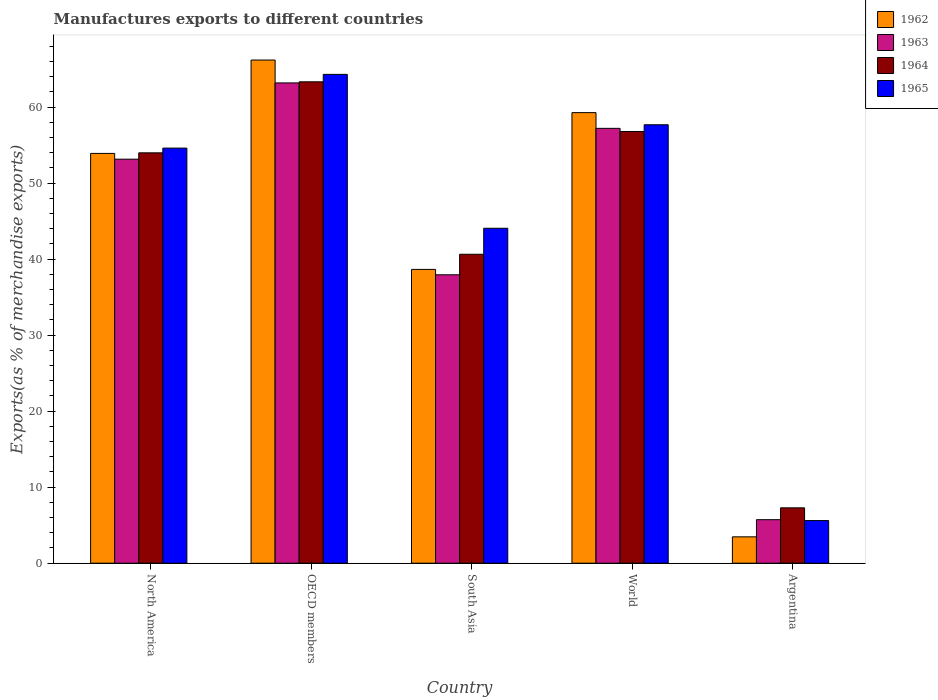How many groups of bars are there?
Provide a succinct answer. 5. Are the number of bars on each tick of the X-axis equal?
Make the answer very short. Yes. What is the label of the 4th group of bars from the left?
Offer a very short reply. World. What is the percentage of exports to different countries in 1962 in OECD members?
Offer a terse response. 66.19. Across all countries, what is the maximum percentage of exports to different countries in 1965?
Make the answer very short. 64.3. Across all countries, what is the minimum percentage of exports to different countries in 1965?
Provide a succinct answer. 5.61. In which country was the percentage of exports to different countries in 1965 maximum?
Give a very brief answer. OECD members. What is the total percentage of exports to different countries in 1962 in the graph?
Offer a terse response. 221.48. What is the difference between the percentage of exports to different countries in 1965 in South Asia and that in World?
Provide a short and direct response. -13.62. What is the difference between the percentage of exports to different countries in 1962 in OECD members and the percentage of exports to different countries in 1965 in South Asia?
Keep it short and to the point. 22.13. What is the average percentage of exports to different countries in 1965 per country?
Keep it short and to the point. 45.25. What is the difference between the percentage of exports to different countries of/in 1962 and percentage of exports to different countries of/in 1965 in Argentina?
Keep it short and to the point. -2.14. What is the ratio of the percentage of exports to different countries in 1962 in North America to that in South Asia?
Your answer should be very brief. 1.39. What is the difference between the highest and the second highest percentage of exports to different countries in 1962?
Your answer should be compact. 6.92. What is the difference between the highest and the lowest percentage of exports to different countries in 1964?
Offer a terse response. 56.04. Is the sum of the percentage of exports to different countries in 1964 in Argentina and North America greater than the maximum percentage of exports to different countries in 1962 across all countries?
Keep it short and to the point. No. Is it the case that in every country, the sum of the percentage of exports to different countries in 1964 and percentage of exports to different countries in 1963 is greater than the sum of percentage of exports to different countries in 1962 and percentage of exports to different countries in 1965?
Give a very brief answer. No. What does the 2nd bar from the left in North America represents?
Ensure brevity in your answer.  1963. What does the 3rd bar from the right in Argentina represents?
Keep it short and to the point. 1963. How many countries are there in the graph?
Make the answer very short. 5. What is the title of the graph?
Provide a succinct answer. Manufactures exports to different countries. Does "1967" appear as one of the legend labels in the graph?
Provide a short and direct response. No. What is the label or title of the Y-axis?
Give a very brief answer. Exports(as % of merchandise exports). What is the Exports(as % of merchandise exports) in 1962 in North America?
Keep it short and to the point. 53.91. What is the Exports(as % of merchandise exports) of 1963 in North America?
Provide a short and direct response. 53.15. What is the Exports(as % of merchandise exports) of 1964 in North America?
Your answer should be very brief. 53.98. What is the Exports(as % of merchandise exports) in 1965 in North America?
Offer a terse response. 54.61. What is the Exports(as % of merchandise exports) in 1962 in OECD members?
Ensure brevity in your answer.  66.19. What is the Exports(as % of merchandise exports) of 1963 in OECD members?
Ensure brevity in your answer.  63.18. What is the Exports(as % of merchandise exports) of 1964 in OECD members?
Make the answer very short. 63.32. What is the Exports(as % of merchandise exports) in 1965 in OECD members?
Ensure brevity in your answer.  64.3. What is the Exports(as % of merchandise exports) in 1962 in South Asia?
Provide a succinct answer. 38.65. What is the Exports(as % of merchandise exports) in 1963 in South Asia?
Your answer should be very brief. 37.94. What is the Exports(as % of merchandise exports) in 1964 in South Asia?
Your response must be concise. 40.64. What is the Exports(as % of merchandise exports) in 1965 in South Asia?
Provide a succinct answer. 44.06. What is the Exports(as % of merchandise exports) in 1962 in World?
Make the answer very short. 59.27. What is the Exports(as % of merchandise exports) of 1963 in World?
Make the answer very short. 57.2. What is the Exports(as % of merchandise exports) of 1964 in World?
Your answer should be very brief. 56.79. What is the Exports(as % of merchandise exports) of 1965 in World?
Your answer should be compact. 57.68. What is the Exports(as % of merchandise exports) in 1962 in Argentina?
Make the answer very short. 3.47. What is the Exports(as % of merchandise exports) in 1963 in Argentina?
Offer a terse response. 5.73. What is the Exports(as % of merchandise exports) in 1964 in Argentina?
Keep it short and to the point. 7.28. What is the Exports(as % of merchandise exports) in 1965 in Argentina?
Your answer should be compact. 5.61. Across all countries, what is the maximum Exports(as % of merchandise exports) in 1962?
Give a very brief answer. 66.19. Across all countries, what is the maximum Exports(as % of merchandise exports) in 1963?
Your answer should be compact. 63.18. Across all countries, what is the maximum Exports(as % of merchandise exports) of 1964?
Give a very brief answer. 63.32. Across all countries, what is the maximum Exports(as % of merchandise exports) in 1965?
Your answer should be compact. 64.3. Across all countries, what is the minimum Exports(as % of merchandise exports) in 1962?
Offer a terse response. 3.47. Across all countries, what is the minimum Exports(as % of merchandise exports) in 1963?
Your answer should be compact. 5.73. Across all countries, what is the minimum Exports(as % of merchandise exports) in 1964?
Provide a succinct answer. 7.28. Across all countries, what is the minimum Exports(as % of merchandise exports) of 1965?
Provide a succinct answer. 5.61. What is the total Exports(as % of merchandise exports) in 1962 in the graph?
Your response must be concise. 221.48. What is the total Exports(as % of merchandise exports) of 1963 in the graph?
Your answer should be compact. 217.2. What is the total Exports(as % of merchandise exports) in 1964 in the graph?
Your answer should be very brief. 222.02. What is the total Exports(as % of merchandise exports) in 1965 in the graph?
Provide a short and direct response. 226.25. What is the difference between the Exports(as % of merchandise exports) in 1962 in North America and that in OECD members?
Offer a very short reply. -12.28. What is the difference between the Exports(as % of merchandise exports) in 1963 in North America and that in OECD members?
Offer a very short reply. -10.03. What is the difference between the Exports(as % of merchandise exports) of 1964 in North America and that in OECD members?
Make the answer very short. -9.34. What is the difference between the Exports(as % of merchandise exports) in 1965 in North America and that in OECD members?
Your answer should be compact. -9.7. What is the difference between the Exports(as % of merchandise exports) of 1962 in North America and that in South Asia?
Give a very brief answer. 15.26. What is the difference between the Exports(as % of merchandise exports) of 1963 in North America and that in South Asia?
Offer a terse response. 15.21. What is the difference between the Exports(as % of merchandise exports) of 1964 in North America and that in South Asia?
Your answer should be very brief. 13.34. What is the difference between the Exports(as % of merchandise exports) in 1965 in North America and that in South Asia?
Offer a very short reply. 10.54. What is the difference between the Exports(as % of merchandise exports) in 1962 in North America and that in World?
Your answer should be compact. -5.36. What is the difference between the Exports(as % of merchandise exports) in 1963 in North America and that in World?
Make the answer very short. -4.06. What is the difference between the Exports(as % of merchandise exports) in 1964 in North America and that in World?
Provide a succinct answer. -2.81. What is the difference between the Exports(as % of merchandise exports) in 1965 in North America and that in World?
Provide a succinct answer. -3.07. What is the difference between the Exports(as % of merchandise exports) in 1962 in North America and that in Argentina?
Provide a short and direct response. 50.44. What is the difference between the Exports(as % of merchandise exports) in 1963 in North America and that in Argentina?
Offer a terse response. 47.42. What is the difference between the Exports(as % of merchandise exports) in 1964 in North America and that in Argentina?
Provide a short and direct response. 46.7. What is the difference between the Exports(as % of merchandise exports) of 1965 in North America and that in Argentina?
Your response must be concise. 49. What is the difference between the Exports(as % of merchandise exports) in 1962 in OECD members and that in South Asia?
Your answer should be very brief. 27.54. What is the difference between the Exports(as % of merchandise exports) in 1963 in OECD members and that in South Asia?
Offer a very short reply. 25.24. What is the difference between the Exports(as % of merchandise exports) of 1964 in OECD members and that in South Asia?
Keep it short and to the point. 22.68. What is the difference between the Exports(as % of merchandise exports) in 1965 in OECD members and that in South Asia?
Make the answer very short. 20.24. What is the difference between the Exports(as % of merchandise exports) in 1962 in OECD members and that in World?
Your answer should be very brief. 6.92. What is the difference between the Exports(as % of merchandise exports) of 1963 in OECD members and that in World?
Your response must be concise. 5.98. What is the difference between the Exports(as % of merchandise exports) of 1964 in OECD members and that in World?
Ensure brevity in your answer.  6.53. What is the difference between the Exports(as % of merchandise exports) of 1965 in OECD members and that in World?
Give a very brief answer. 6.63. What is the difference between the Exports(as % of merchandise exports) of 1962 in OECD members and that in Argentina?
Provide a succinct answer. 62.72. What is the difference between the Exports(as % of merchandise exports) of 1963 in OECD members and that in Argentina?
Offer a very short reply. 57.46. What is the difference between the Exports(as % of merchandise exports) in 1964 in OECD members and that in Argentina?
Make the answer very short. 56.04. What is the difference between the Exports(as % of merchandise exports) of 1965 in OECD members and that in Argentina?
Give a very brief answer. 58.69. What is the difference between the Exports(as % of merchandise exports) in 1962 in South Asia and that in World?
Give a very brief answer. -20.62. What is the difference between the Exports(as % of merchandise exports) in 1963 in South Asia and that in World?
Your answer should be compact. -19.26. What is the difference between the Exports(as % of merchandise exports) in 1964 in South Asia and that in World?
Your answer should be compact. -16.15. What is the difference between the Exports(as % of merchandise exports) of 1965 in South Asia and that in World?
Provide a succinct answer. -13.62. What is the difference between the Exports(as % of merchandise exports) in 1962 in South Asia and that in Argentina?
Give a very brief answer. 35.18. What is the difference between the Exports(as % of merchandise exports) in 1963 in South Asia and that in Argentina?
Your answer should be very brief. 32.21. What is the difference between the Exports(as % of merchandise exports) of 1964 in South Asia and that in Argentina?
Make the answer very short. 33.36. What is the difference between the Exports(as % of merchandise exports) of 1965 in South Asia and that in Argentina?
Your answer should be compact. 38.45. What is the difference between the Exports(as % of merchandise exports) of 1962 in World and that in Argentina?
Give a very brief answer. 55.8. What is the difference between the Exports(as % of merchandise exports) in 1963 in World and that in Argentina?
Provide a succinct answer. 51.48. What is the difference between the Exports(as % of merchandise exports) of 1964 in World and that in Argentina?
Give a very brief answer. 49.51. What is the difference between the Exports(as % of merchandise exports) of 1965 in World and that in Argentina?
Your answer should be compact. 52.07. What is the difference between the Exports(as % of merchandise exports) in 1962 in North America and the Exports(as % of merchandise exports) in 1963 in OECD members?
Make the answer very short. -9.27. What is the difference between the Exports(as % of merchandise exports) of 1962 in North America and the Exports(as % of merchandise exports) of 1964 in OECD members?
Provide a short and direct response. -9.42. What is the difference between the Exports(as % of merchandise exports) in 1962 in North America and the Exports(as % of merchandise exports) in 1965 in OECD members?
Make the answer very short. -10.4. What is the difference between the Exports(as % of merchandise exports) in 1963 in North America and the Exports(as % of merchandise exports) in 1964 in OECD members?
Ensure brevity in your answer.  -10.18. What is the difference between the Exports(as % of merchandise exports) in 1963 in North America and the Exports(as % of merchandise exports) in 1965 in OECD members?
Offer a terse response. -11.15. What is the difference between the Exports(as % of merchandise exports) of 1964 in North America and the Exports(as % of merchandise exports) of 1965 in OECD members?
Give a very brief answer. -10.32. What is the difference between the Exports(as % of merchandise exports) in 1962 in North America and the Exports(as % of merchandise exports) in 1963 in South Asia?
Your answer should be compact. 15.97. What is the difference between the Exports(as % of merchandise exports) of 1962 in North America and the Exports(as % of merchandise exports) of 1964 in South Asia?
Make the answer very short. 13.27. What is the difference between the Exports(as % of merchandise exports) of 1962 in North America and the Exports(as % of merchandise exports) of 1965 in South Asia?
Make the answer very short. 9.85. What is the difference between the Exports(as % of merchandise exports) of 1963 in North America and the Exports(as % of merchandise exports) of 1964 in South Asia?
Keep it short and to the point. 12.51. What is the difference between the Exports(as % of merchandise exports) in 1963 in North America and the Exports(as % of merchandise exports) in 1965 in South Asia?
Give a very brief answer. 9.09. What is the difference between the Exports(as % of merchandise exports) of 1964 in North America and the Exports(as % of merchandise exports) of 1965 in South Asia?
Your response must be concise. 9.92. What is the difference between the Exports(as % of merchandise exports) in 1962 in North America and the Exports(as % of merchandise exports) in 1963 in World?
Your answer should be compact. -3.3. What is the difference between the Exports(as % of merchandise exports) of 1962 in North America and the Exports(as % of merchandise exports) of 1964 in World?
Your answer should be compact. -2.88. What is the difference between the Exports(as % of merchandise exports) of 1962 in North America and the Exports(as % of merchandise exports) of 1965 in World?
Give a very brief answer. -3.77. What is the difference between the Exports(as % of merchandise exports) of 1963 in North America and the Exports(as % of merchandise exports) of 1964 in World?
Your answer should be very brief. -3.64. What is the difference between the Exports(as % of merchandise exports) in 1963 in North America and the Exports(as % of merchandise exports) in 1965 in World?
Ensure brevity in your answer.  -4.53. What is the difference between the Exports(as % of merchandise exports) of 1964 in North America and the Exports(as % of merchandise exports) of 1965 in World?
Offer a terse response. -3.69. What is the difference between the Exports(as % of merchandise exports) in 1962 in North America and the Exports(as % of merchandise exports) in 1963 in Argentina?
Keep it short and to the point. 48.18. What is the difference between the Exports(as % of merchandise exports) in 1962 in North America and the Exports(as % of merchandise exports) in 1964 in Argentina?
Provide a succinct answer. 46.62. What is the difference between the Exports(as % of merchandise exports) of 1962 in North America and the Exports(as % of merchandise exports) of 1965 in Argentina?
Give a very brief answer. 48.3. What is the difference between the Exports(as % of merchandise exports) in 1963 in North America and the Exports(as % of merchandise exports) in 1964 in Argentina?
Offer a terse response. 45.87. What is the difference between the Exports(as % of merchandise exports) in 1963 in North America and the Exports(as % of merchandise exports) in 1965 in Argentina?
Keep it short and to the point. 47.54. What is the difference between the Exports(as % of merchandise exports) in 1964 in North America and the Exports(as % of merchandise exports) in 1965 in Argentina?
Your response must be concise. 48.37. What is the difference between the Exports(as % of merchandise exports) of 1962 in OECD members and the Exports(as % of merchandise exports) of 1963 in South Asia?
Ensure brevity in your answer.  28.25. What is the difference between the Exports(as % of merchandise exports) in 1962 in OECD members and the Exports(as % of merchandise exports) in 1964 in South Asia?
Give a very brief answer. 25.55. What is the difference between the Exports(as % of merchandise exports) in 1962 in OECD members and the Exports(as % of merchandise exports) in 1965 in South Asia?
Ensure brevity in your answer.  22.13. What is the difference between the Exports(as % of merchandise exports) of 1963 in OECD members and the Exports(as % of merchandise exports) of 1964 in South Asia?
Offer a terse response. 22.54. What is the difference between the Exports(as % of merchandise exports) of 1963 in OECD members and the Exports(as % of merchandise exports) of 1965 in South Asia?
Your answer should be very brief. 19.12. What is the difference between the Exports(as % of merchandise exports) in 1964 in OECD members and the Exports(as % of merchandise exports) in 1965 in South Asia?
Your response must be concise. 19.26. What is the difference between the Exports(as % of merchandise exports) of 1962 in OECD members and the Exports(as % of merchandise exports) of 1963 in World?
Make the answer very short. 8.99. What is the difference between the Exports(as % of merchandise exports) of 1962 in OECD members and the Exports(as % of merchandise exports) of 1964 in World?
Your answer should be compact. 9.4. What is the difference between the Exports(as % of merchandise exports) of 1962 in OECD members and the Exports(as % of merchandise exports) of 1965 in World?
Give a very brief answer. 8.51. What is the difference between the Exports(as % of merchandise exports) in 1963 in OECD members and the Exports(as % of merchandise exports) in 1964 in World?
Give a very brief answer. 6.39. What is the difference between the Exports(as % of merchandise exports) of 1963 in OECD members and the Exports(as % of merchandise exports) of 1965 in World?
Your response must be concise. 5.5. What is the difference between the Exports(as % of merchandise exports) in 1964 in OECD members and the Exports(as % of merchandise exports) in 1965 in World?
Keep it short and to the point. 5.65. What is the difference between the Exports(as % of merchandise exports) of 1962 in OECD members and the Exports(as % of merchandise exports) of 1963 in Argentina?
Keep it short and to the point. 60.46. What is the difference between the Exports(as % of merchandise exports) in 1962 in OECD members and the Exports(as % of merchandise exports) in 1964 in Argentina?
Ensure brevity in your answer.  58.91. What is the difference between the Exports(as % of merchandise exports) in 1962 in OECD members and the Exports(as % of merchandise exports) in 1965 in Argentina?
Your answer should be compact. 60.58. What is the difference between the Exports(as % of merchandise exports) of 1963 in OECD members and the Exports(as % of merchandise exports) of 1964 in Argentina?
Your response must be concise. 55.9. What is the difference between the Exports(as % of merchandise exports) in 1963 in OECD members and the Exports(as % of merchandise exports) in 1965 in Argentina?
Give a very brief answer. 57.57. What is the difference between the Exports(as % of merchandise exports) in 1964 in OECD members and the Exports(as % of merchandise exports) in 1965 in Argentina?
Give a very brief answer. 57.71. What is the difference between the Exports(as % of merchandise exports) of 1962 in South Asia and the Exports(as % of merchandise exports) of 1963 in World?
Provide a short and direct response. -18.56. What is the difference between the Exports(as % of merchandise exports) in 1962 in South Asia and the Exports(as % of merchandise exports) in 1964 in World?
Provide a succinct answer. -18.14. What is the difference between the Exports(as % of merchandise exports) in 1962 in South Asia and the Exports(as % of merchandise exports) in 1965 in World?
Offer a terse response. -19.03. What is the difference between the Exports(as % of merchandise exports) in 1963 in South Asia and the Exports(as % of merchandise exports) in 1964 in World?
Your response must be concise. -18.85. What is the difference between the Exports(as % of merchandise exports) of 1963 in South Asia and the Exports(as % of merchandise exports) of 1965 in World?
Offer a terse response. -19.74. What is the difference between the Exports(as % of merchandise exports) of 1964 in South Asia and the Exports(as % of merchandise exports) of 1965 in World?
Keep it short and to the point. -17.04. What is the difference between the Exports(as % of merchandise exports) of 1962 in South Asia and the Exports(as % of merchandise exports) of 1963 in Argentina?
Your response must be concise. 32.92. What is the difference between the Exports(as % of merchandise exports) in 1962 in South Asia and the Exports(as % of merchandise exports) in 1964 in Argentina?
Your answer should be compact. 31.37. What is the difference between the Exports(as % of merchandise exports) of 1962 in South Asia and the Exports(as % of merchandise exports) of 1965 in Argentina?
Your response must be concise. 33.04. What is the difference between the Exports(as % of merchandise exports) in 1963 in South Asia and the Exports(as % of merchandise exports) in 1964 in Argentina?
Your answer should be very brief. 30.66. What is the difference between the Exports(as % of merchandise exports) in 1963 in South Asia and the Exports(as % of merchandise exports) in 1965 in Argentina?
Give a very brief answer. 32.33. What is the difference between the Exports(as % of merchandise exports) of 1964 in South Asia and the Exports(as % of merchandise exports) of 1965 in Argentina?
Your response must be concise. 35.03. What is the difference between the Exports(as % of merchandise exports) in 1962 in World and the Exports(as % of merchandise exports) in 1963 in Argentina?
Your answer should be very brief. 53.55. What is the difference between the Exports(as % of merchandise exports) of 1962 in World and the Exports(as % of merchandise exports) of 1964 in Argentina?
Give a very brief answer. 51.99. What is the difference between the Exports(as % of merchandise exports) in 1962 in World and the Exports(as % of merchandise exports) in 1965 in Argentina?
Provide a succinct answer. 53.66. What is the difference between the Exports(as % of merchandise exports) of 1963 in World and the Exports(as % of merchandise exports) of 1964 in Argentina?
Make the answer very short. 49.92. What is the difference between the Exports(as % of merchandise exports) of 1963 in World and the Exports(as % of merchandise exports) of 1965 in Argentina?
Your answer should be compact. 51.59. What is the difference between the Exports(as % of merchandise exports) of 1964 in World and the Exports(as % of merchandise exports) of 1965 in Argentina?
Your answer should be very brief. 51.18. What is the average Exports(as % of merchandise exports) of 1962 per country?
Offer a very short reply. 44.3. What is the average Exports(as % of merchandise exports) in 1963 per country?
Your answer should be compact. 43.44. What is the average Exports(as % of merchandise exports) of 1964 per country?
Offer a terse response. 44.4. What is the average Exports(as % of merchandise exports) in 1965 per country?
Give a very brief answer. 45.25. What is the difference between the Exports(as % of merchandise exports) of 1962 and Exports(as % of merchandise exports) of 1963 in North America?
Keep it short and to the point. 0.76. What is the difference between the Exports(as % of merchandise exports) of 1962 and Exports(as % of merchandise exports) of 1964 in North America?
Your answer should be very brief. -0.08. What is the difference between the Exports(as % of merchandise exports) in 1962 and Exports(as % of merchandise exports) in 1965 in North America?
Your answer should be very brief. -0.7. What is the difference between the Exports(as % of merchandise exports) in 1963 and Exports(as % of merchandise exports) in 1964 in North America?
Offer a terse response. -0.84. What is the difference between the Exports(as % of merchandise exports) in 1963 and Exports(as % of merchandise exports) in 1965 in North America?
Offer a very short reply. -1.46. What is the difference between the Exports(as % of merchandise exports) in 1964 and Exports(as % of merchandise exports) in 1965 in North America?
Your response must be concise. -0.62. What is the difference between the Exports(as % of merchandise exports) in 1962 and Exports(as % of merchandise exports) in 1963 in OECD members?
Keep it short and to the point. 3.01. What is the difference between the Exports(as % of merchandise exports) in 1962 and Exports(as % of merchandise exports) in 1964 in OECD members?
Keep it short and to the point. 2.87. What is the difference between the Exports(as % of merchandise exports) of 1962 and Exports(as % of merchandise exports) of 1965 in OECD members?
Your response must be concise. 1.89. What is the difference between the Exports(as % of merchandise exports) in 1963 and Exports(as % of merchandise exports) in 1964 in OECD members?
Your answer should be compact. -0.14. What is the difference between the Exports(as % of merchandise exports) in 1963 and Exports(as % of merchandise exports) in 1965 in OECD members?
Offer a terse response. -1.12. What is the difference between the Exports(as % of merchandise exports) of 1964 and Exports(as % of merchandise exports) of 1965 in OECD members?
Make the answer very short. -0.98. What is the difference between the Exports(as % of merchandise exports) of 1962 and Exports(as % of merchandise exports) of 1963 in South Asia?
Keep it short and to the point. 0.71. What is the difference between the Exports(as % of merchandise exports) in 1962 and Exports(as % of merchandise exports) in 1964 in South Asia?
Provide a short and direct response. -1.99. What is the difference between the Exports(as % of merchandise exports) of 1962 and Exports(as % of merchandise exports) of 1965 in South Asia?
Provide a succinct answer. -5.41. What is the difference between the Exports(as % of merchandise exports) in 1963 and Exports(as % of merchandise exports) in 1964 in South Asia?
Provide a short and direct response. -2.7. What is the difference between the Exports(as % of merchandise exports) in 1963 and Exports(as % of merchandise exports) in 1965 in South Asia?
Offer a terse response. -6.12. What is the difference between the Exports(as % of merchandise exports) in 1964 and Exports(as % of merchandise exports) in 1965 in South Asia?
Provide a short and direct response. -3.42. What is the difference between the Exports(as % of merchandise exports) in 1962 and Exports(as % of merchandise exports) in 1963 in World?
Make the answer very short. 2.07. What is the difference between the Exports(as % of merchandise exports) of 1962 and Exports(as % of merchandise exports) of 1964 in World?
Offer a terse response. 2.48. What is the difference between the Exports(as % of merchandise exports) of 1962 and Exports(as % of merchandise exports) of 1965 in World?
Your answer should be compact. 1.59. What is the difference between the Exports(as % of merchandise exports) in 1963 and Exports(as % of merchandise exports) in 1964 in World?
Ensure brevity in your answer.  0.41. What is the difference between the Exports(as % of merchandise exports) in 1963 and Exports(as % of merchandise exports) in 1965 in World?
Provide a short and direct response. -0.47. What is the difference between the Exports(as % of merchandise exports) in 1964 and Exports(as % of merchandise exports) in 1965 in World?
Your answer should be very brief. -0.89. What is the difference between the Exports(as % of merchandise exports) of 1962 and Exports(as % of merchandise exports) of 1963 in Argentina?
Give a very brief answer. -2.26. What is the difference between the Exports(as % of merchandise exports) of 1962 and Exports(as % of merchandise exports) of 1964 in Argentina?
Make the answer very short. -3.81. What is the difference between the Exports(as % of merchandise exports) of 1962 and Exports(as % of merchandise exports) of 1965 in Argentina?
Keep it short and to the point. -2.14. What is the difference between the Exports(as % of merchandise exports) of 1963 and Exports(as % of merchandise exports) of 1964 in Argentina?
Your answer should be very brief. -1.56. What is the difference between the Exports(as % of merchandise exports) in 1963 and Exports(as % of merchandise exports) in 1965 in Argentina?
Your response must be concise. 0.12. What is the difference between the Exports(as % of merchandise exports) of 1964 and Exports(as % of merchandise exports) of 1965 in Argentina?
Provide a succinct answer. 1.67. What is the ratio of the Exports(as % of merchandise exports) in 1962 in North America to that in OECD members?
Your answer should be very brief. 0.81. What is the ratio of the Exports(as % of merchandise exports) of 1963 in North America to that in OECD members?
Your answer should be compact. 0.84. What is the ratio of the Exports(as % of merchandise exports) in 1964 in North America to that in OECD members?
Your response must be concise. 0.85. What is the ratio of the Exports(as % of merchandise exports) of 1965 in North America to that in OECD members?
Offer a terse response. 0.85. What is the ratio of the Exports(as % of merchandise exports) of 1962 in North America to that in South Asia?
Offer a very short reply. 1.39. What is the ratio of the Exports(as % of merchandise exports) of 1963 in North America to that in South Asia?
Offer a terse response. 1.4. What is the ratio of the Exports(as % of merchandise exports) of 1964 in North America to that in South Asia?
Keep it short and to the point. 1.33. What is the ratio of the Exports(as % of merchandise exports) in 1965 in North America to that in South Asia?
Your response must be concise. 1.24. What is the ratio of the Exports(as % of merchandise exports) in 1962 in North America to that in World?
Your response must be concise. 0.91. What is the ratio of the Exports(as % of merchandise exports) of 1963 in North America to that in World?
Give a very brief answer. 0.93. What is the ratio of the Exports(as % of merchandise exports) in 1964 in North America to that in World?
Keep it short and to the point. 0.95. What is the ratio of the Exports(as % of merchandise exports) of 1965 in North America to that in World?
Give a very brief answer. 0.95. What is the ratio of the Exports(as % of merchandise exports) in 1962 in North America to that in Argentina?
Your answer should be very brief. 15.54. What is the ratio of the Exports(as % of merchandise exports) of 1963 in North America to that in Argentina?
Ensure brevity in your answer.  9.28. What is the ratio of the Exports(as % of merchandise exports) in 1964 in North America to that in Argentina?
Your answer should be compact. 7.41. What is the ratio of the Exports(as % of merchandise exports) of 1965 in North America to that in Argentina?
Provide a short and direct response. 9.74. What is the ratio of the Exports(as % of merchandise exports) of 1962 in OECD members to that in South Asia?
Offer a very short reply. 1.71. What is the ratio of the Exports(as % of merchandise exports) in 1963 in OECD members to that in South Asia?
Offer a terse response. 1.67. What is the ratio of the Exports(as % of merchandise exports) in 1964 in OECD members to that in South Asia?
Make the answer very short. 1.56. What is the ratio of the Exports(as % of merchandise exports) of 1965 in OECD members to that in South Asia?
Give a very brief answer. 1.46. What is the ratio of the Exports(as % of merchandise exports) of 1962 in OECD members to that in World?
Keep it short and to the point. 1.12. What is the ratio of the Exports(as % of merchandise exports) of 1963 in OECD members to that in World?
Provide a short and direct response. 1.1. What is the ratio of the Exports(as % of merchandise exports) of 1964 in OECD members to that in World?
Your answer should be compact. 1.12. What is the ratio of the Exports(as % of merchandise exports) in 1965 in OECD members to that in World?
Keep it short and to the point. 1.11. What is the ratio of the Exports(as % of merchandise exports) of 1962 in OECD members to that in Argentina?
Your answer should be compact. 19.09. What is the ratio of the Exports(as % of merchandise exports) in 1963 in OECD members to that in Argentina?
Your answer should be very brief. 11.03. What is the ratio of the Exports(as % of merchandise exports) of 1964 in OECD members to that in Argentina?
Your response must be concise. 8.7. What is the ratio of the Exports(as % of merchandise exports) in 1965 in OECD members to that in Argentina?
Give a very brief answer. 11.46. What is the ratio of the Exports(as % of merchandise exports) in 1962 in South Asia to that in World?
Give a very brief answer. 0.65. What is the ratio of the Exports(as % of merchandise exports) of 1963 in South Asia to that in World?
Keep it short and to the point. 0.66. What is the ratio of the Exports(as % of merchandise exports) of 1964 in South Asia to that in World?
Provide a short and direct response. 0.72. What is the ratio of the Exports(as % of merchandise exports) of 1965 in South Asia to that in World?
Your answer should be compact. 0.76. What is the ratio of the Exports(as % of merchandise exports) of 1962 in South Asia to that in Argentina?
Offer a terse response. 11.14. What is the ratio of the Exports(as % of merchandise exports) in 1963 in South Asia to that in Argentina?
Your answer should be very brief. 6.63. What is the ratio of the Exports(as % of merchandise exports) of 1964 in South Asia to that in Argentina?
Offer a terse response. 5.58. What is the ratio of the Exports(as % of merchandise exports) in 1965 in South Asia to that in Argentina?
Provide a succinct answer. 7.86. What is the ratio of the Exports(as % of merchandise exports) of 1962 in World to that in Argentina?
Provide a short and direct response. 17.09. What is the ratio of the Exports(as % of merchandise exports) of 1963 in World to that in Argentina?
Make the answer very short. 9.99. What is the ratio of the Exports(as % of merchandise exports) in 1964 in World to that in Argentina?
Offer a terse response. 7.8. What is the ratio of the Exports(as % of merchandise exports) in 1965 in World to that in Argentina?
Provide a short and direct response. 10.28. What is the difference between the highest and the second highest Exports(as % of merchandise exports) in 1962?
Give a very brief answer. 6.92. What is the difference between the highest and the second highest Exports(as % of merchandise exports) of 1963?
Your answer should be very brief. 5.98. What is the difference between the highest and the second highest Exports(as % of merchandise exports) of 1964?
Give a very brief answer. 6.53. What is the difference between the highest and the second highest Exports(as % of merchandise exports) of 1965?
Your response must be concise. 6.63. What is the difference between the highest and the lowest Exports(as % of merchandise exports) in 1962?
Give a very brief answer. 62.72. What is the difference between the highest and the lowest Exports(as % of merchandise exports) in 1963?
Offer a terse response. 57.46. What is the difference between the highest and the lowest Exports(as % of merchandise exports) in 1964?
Provide a short and direct response. 56.04. What is the difference between the highest and the lowest Exports(as % of merchandise exports) of 1965?
Provide a succinct answer. 58.69. 